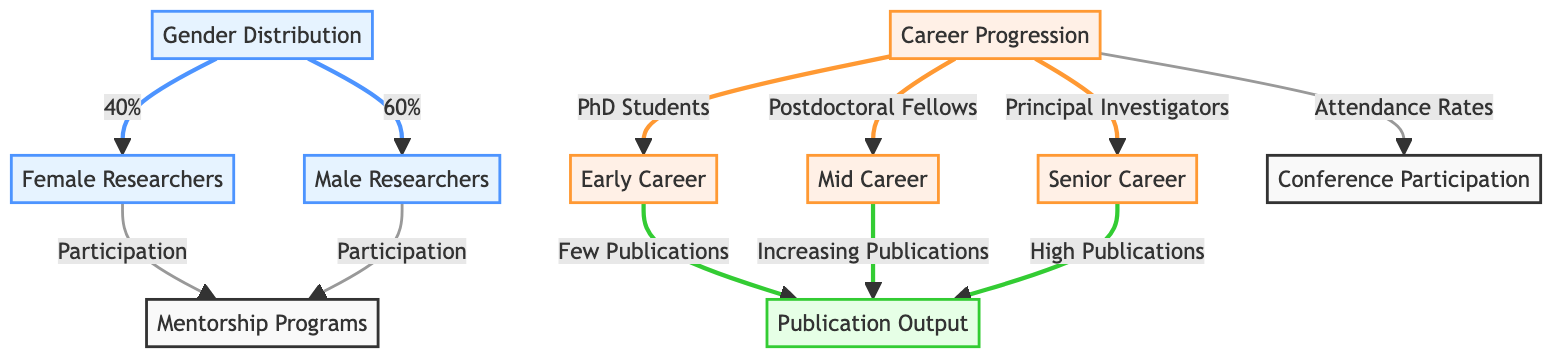What is the percentage of female researchers in the diagram? The diagram states that the gender distribution shows 40% of researchers are female. Therefore, the answer can be directly found in the gender distribution node.
Answer: 40% How many career progression stages are identified in the diagram? The diagram includes three stages of career progression: early career, mid career, and senior career. By counting these nodes, we find the number of stages.
Answer: 3 What is the publication output pattern for senior career researchers? The diagram indicates that senior career researchers have "High Publications" as their output. The information is clearly stated under the senior career node connected to publication output.
Answer: High Publications What type of participation is noted for both female and male researchers in mentorship programs? Both female and male researchers have their participation in mentorship programs indicated in the diagram. The arrows leading to the mentorship programs node from both gender categories confirm this shared involvement.
Answer: Participation Which node is connected to early career researchers in terms of publication output? In the diagram, early career researchers are linked to "Few Publications" under publication output. This can be inferred by following the path from early career to publication output.
Answer: Few Publications What is the key difference in publication output between mid-career and senior career stages? The diagram illustrates that mid-career researchers have "Increasing Publications" while senior career researchers achieve "High Publications." Comparing these outputs shows the progression in the publication output as researchers advance in their careers.
Answer: Increasing Publications and High Publications How is conference participation related to career progression? The diagram highlights that conference participation is tied to attendance rates, which are related to different career stages, including early career, mid career, and senior career. This indicates that conference participation increases as researchers progress.
Answer: Attendance Rates What percentage of researchers are male according to the diagram? The diagram states that 60% of the researchers are male, which can be found directly in the gender distribution node linked to male researchers.
Answer: 60% 